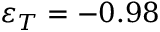Convert formula to latex. <formula><loc_0><loc_0><loc_500><loc_500>\varepsilon _ { T } = - 0 . 9 8</formula> 